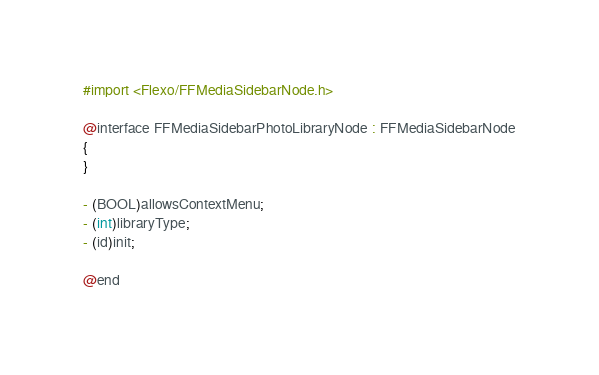<code> <loc_0><loc_0><loc_500><loc_500><_C_>#import <Flexo/FFMediaSidebarNode.h>

@interface FFMediaSidebarPhotoLibraryNode : FFMediaSidebarNode
{
}

- (BOOL)allowsContextMenu;
- (int)libraryType;
- (id)init;

@end

</code> 